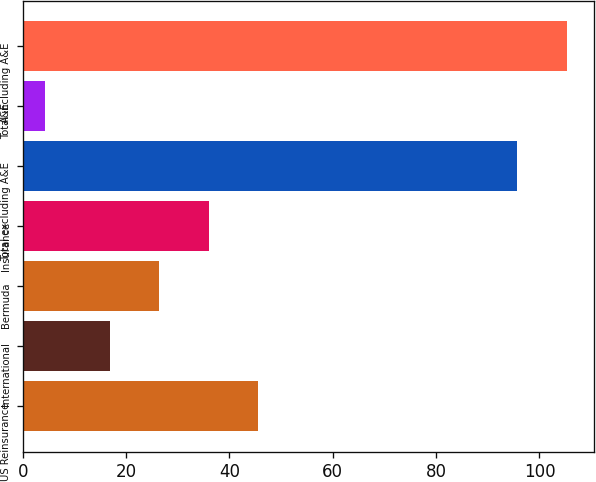<chart> <loc_0><loc_0><loc_500><loc_500><bar_chart><fcel>US Reinsurance<fcel>International<fcel>Bermuda<fcel>Insurance<fcel>Total excluding A&E<fcel>A&E<fcel>Total including A&E<nl><fcel>45.61<fcel>16.9<fcel>26.47<fcel>36.04<fcel>95.7<fcel>4.3<fcel>105.27<nl></chart> 